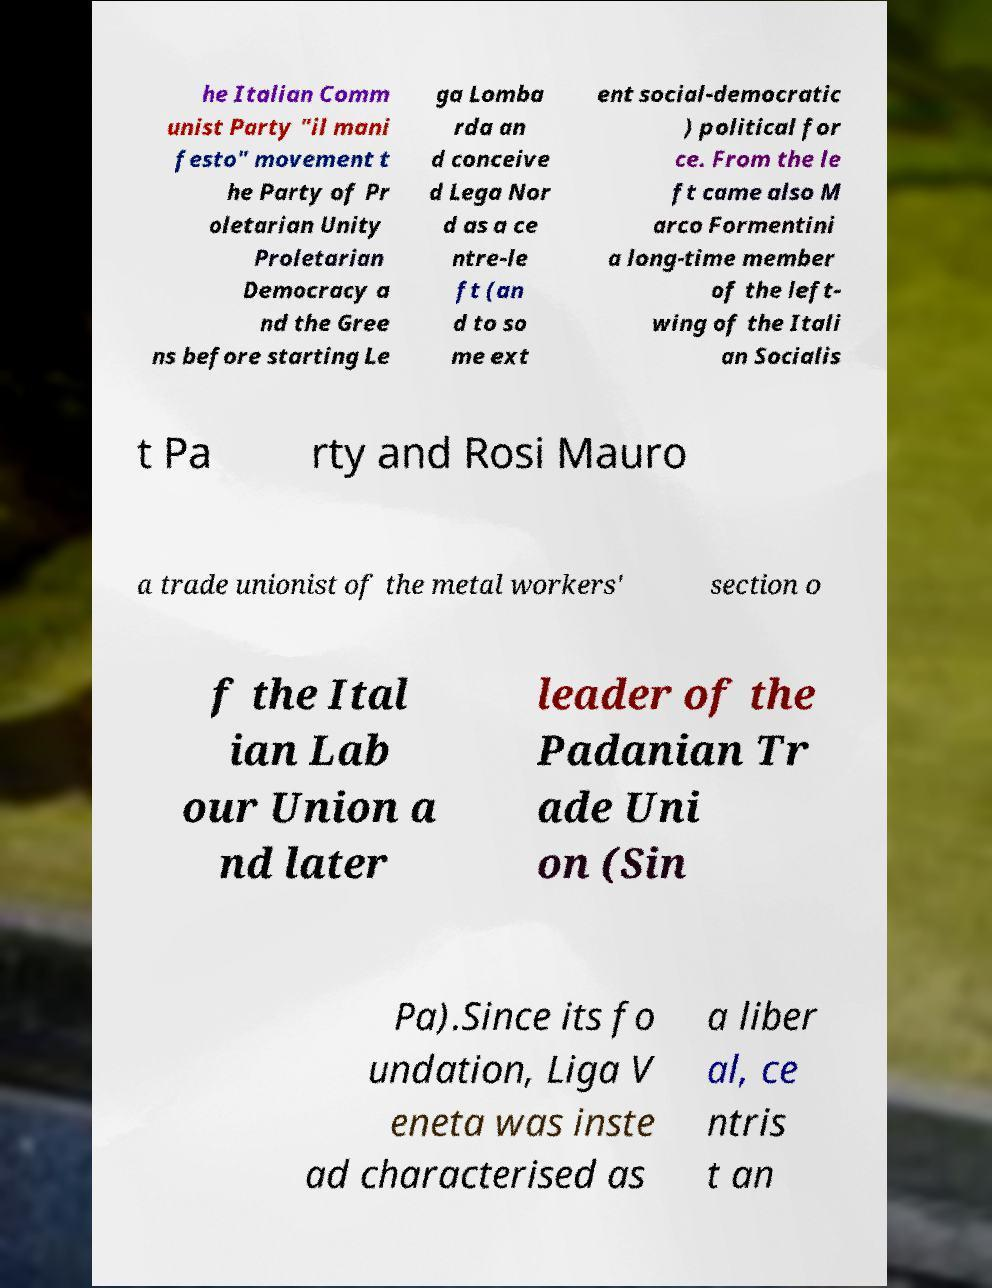For documentation purposes, I need the text within this image transcribed. Could you provide that? he Italian Comm unist Party "il mani festo" movement t he Party of Pr oletarian Unity Proletarian Democracy a nd the Gree ns before starting Le ga Lomba rda an d conceive d Lega Nor d as a ce ntre-le ft (an d to so me ext ent social-democratic ) political for ce. From the le ft came also M arco Formentini a long-time member of the left- wing of the Itali an Socialis t Pa rty and Rosi Mauro a trade unionist of the metal workers' section o f the Ital ian Lab our Union a nd later leader of the Padanian Tr ade Uni on (Sin Pa).Since its fo undation, Liga V eneta was inste ad characterised as a liber al, ce ntris t an 